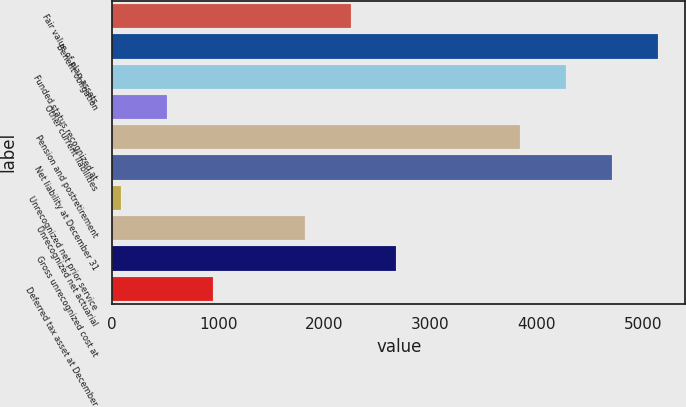Convert chart. <chart><loc_0><loc_0><loc_500><loc_500><bar_chart><fcel>Fair value of plan assets<fcel>Benefit obligation<fcel>Funded status recognized at<fcel>Other current liabilities<fcel>Pension and postretirement<fcel>Net liability at December 31<fcel>Unrecognized net prior service<fcel>Unrecognized net actuarial<fcel>Gross unrecognized cost at<fcel>Deferred tax asset at December<nl><fcel>2245.5<fcel>5143.9<fcel>4277.3<fcel>512.3<fcel>3844<fcel>4710.6<fcel>79<fcel>1812.2<fcel>2678.8<fcel>945.6<nl></chart> 